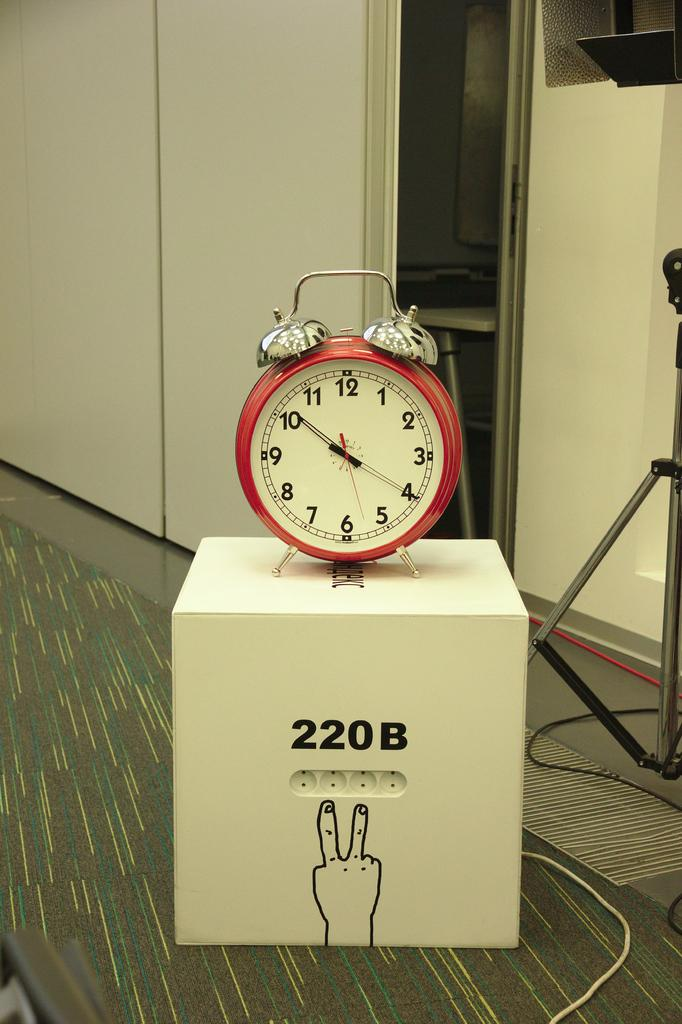<image>
Present a compact description of the photo's key features. a red alarm clock on a box with 220B on it 